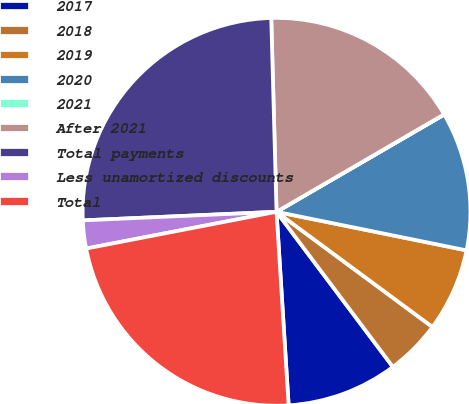<chart> <loc_0><loc_0><loc_500><loc_500><pie_chart><fcel>2017<fcel>2018<fcel>2019<fcel>2020<fcel>2021<fcel>After 2021<fcel>Total payments<fcel>Less unamortized discounts<fcel>Total<nl><fcel>9.25%<fcel>4.63%<fcel>6.94%<fcel>11.55%<fcel>0.02%<fcel>17.05%<fcel>25.27%<fcel>2.33%<fcel>22.96%<nl></chart> 